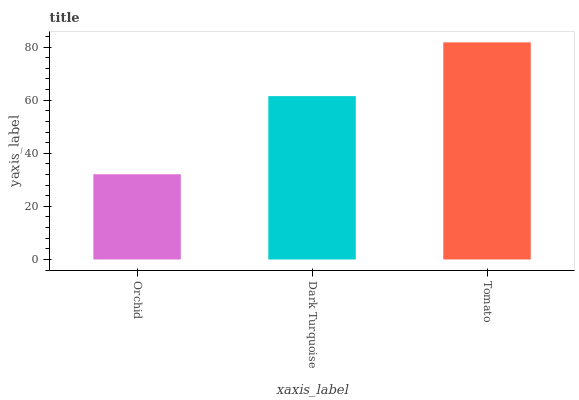Is Dark Turquoise the minimum?
Answer yes or no. No. Is Dark Turquoise the maximum?
Answer yes or no. No. Is Dark Turquoise greater than Orchid?
Answer yes or no. Yes. Is Orchid less than Dark Turquoise?
Answer yes or no. Yes. Is Orchid greater than Dark Turquoise?
Answer yes or no. No. Is Dark Turquoise less than Orchid?
Answer yes or no. No. Is Dark Turquoise the high median?
Answer yes or no. Yes. Is Dark Turquoise the low median?
Answer yes or no. Yes. Is Orchid the high median?
Answer yes or no. No. Is Orchid the low median?
Answer yes or no. No. 